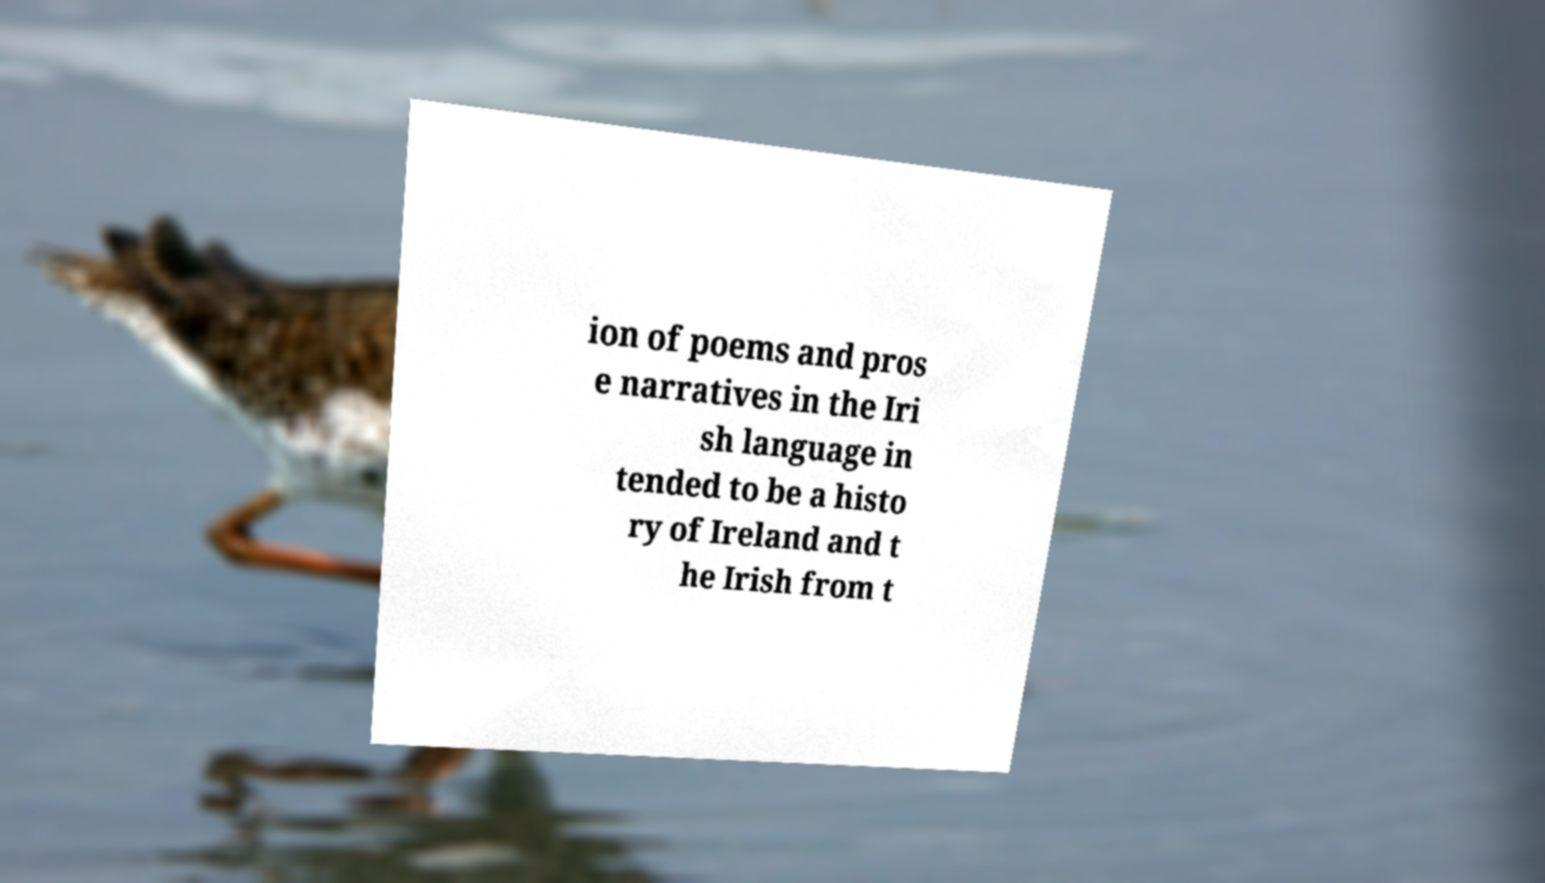For documentation purposes, I need the text within this image transcribed. Could you provide that? ion of poems and pros e narratives in the Iri sh language in tended to be a histo ry of Ireland and t he Irish from t 